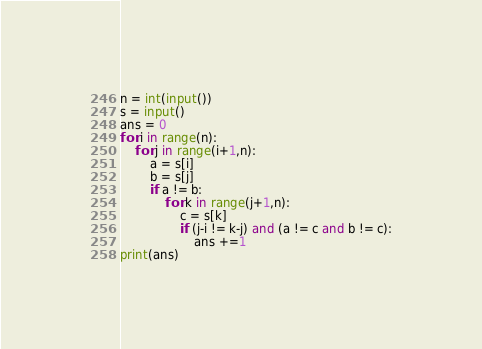<code> <loc_0><loc_0><loc_500><loc_500><_Python_>n = int(input())
s = input()
ans = 0
for i in range(n):
    for j in range(i+1,n):
        a = s[i]
        b = s[j]
        if a != b:
            for k in range(j+1,n):
                c = s[k]
                if (j-i != k-j) and (a != c and b != c):
                    ans +=1
print(ans)
</code> 